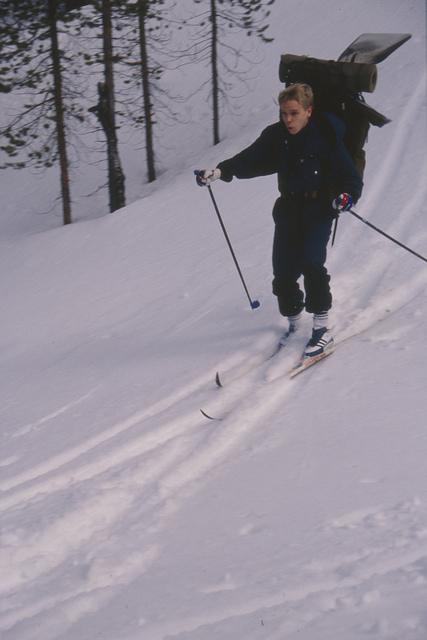What is the shovel carried here meant to be used for first?

Choices:
A) signaling
B) grave digging
C) snow removal
D) coal snow removal 